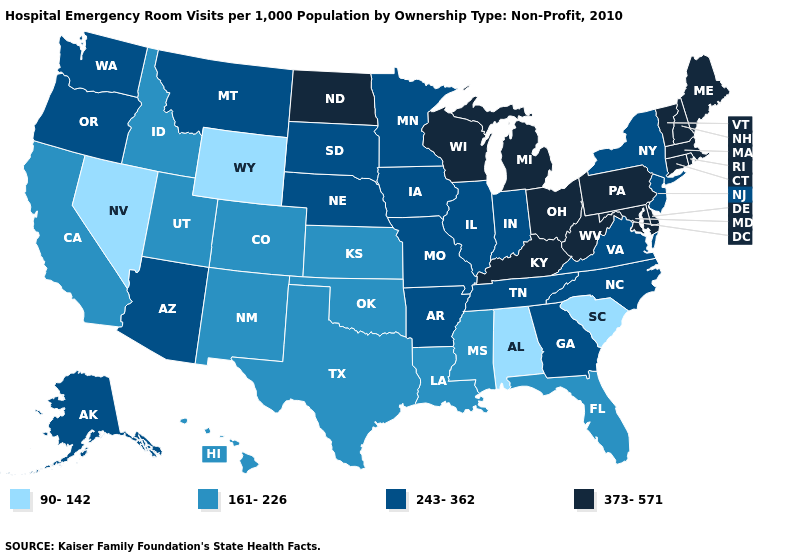Does Texas have the same value as South Carolina?
Write a very short answer. No. Name the states that have a value in the range 90-142?
Answer briefly. Alabama, Nevada, South Carolina, Wyoming. What is the value of New York?
Short answer required. 243-362. Among the states that border California , does Nevada have the highest value?
Quick response, please. No. Name the states that have a value in the range 243-362?
Answer briefly. Alaska, Arizona, Arkansas, Georgia, Illinois, Indiana, Iowa, Minnesota, Missouri, Montana, Nebraska, New Jersey, New York, North Carolina, Oregon, South Dakota, Tennessee, Virginia, Washington. What is the highest value in the USA?
Keep it brief. 373-571. Does Nevada have the lowest value in the West?
Give a very brief answer. Yes. What is the highest value in the MidWest ?
Be succinct. 373-571. Does New Mexico have a lower value than New York?
Concise answer only. Yes. Is the legend a continuous bar?
Quick response, please. No. Among the states that border Illinois , which have the highest value?
Answer briefly. Kentucky, Wisconsin. What is the value of Arkansas?
Be succinct. 243-362. Name the states that have a value in the range 90-142?
Give a very brief answer. Alabama, Nevada, South Carolina, Wyoming. Is the legend a continuous bar?
Give a very brief answer. No. 